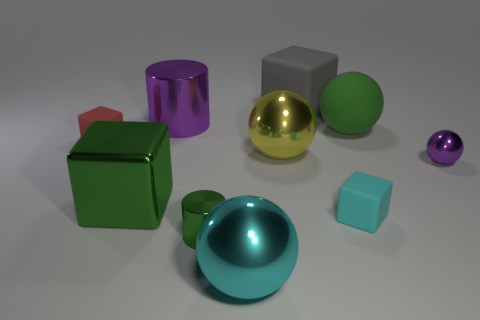Are there fewer green metal things than red rubber objects?
Give a very brief answer. No. How many small purple objects have the same material as the small green cylinder?
Offer a very short reply. 1. There is a small ball that is made of the same material as the tiny green cylinder; what is its color?
Give a very brief answer. Purple. What is the shape of the big yellow object?
Offer a very short reply. Sphere. How many tiny rubber objects have the same color as the rubber sphere?
Provide a succinct answer. 0. There is a yellow metallic object that is the same size as the green shiny block; what shape is it?
Offer a terse response. Sphere. Is there a yellow object that has the same size as the green cube?
Give a very brief answer. Yes. There is a purple ball that is the same size as the red cube; what is its material?
Provide a short and direct response. Metal. How big is the matte cube to the left of the large cyan metallic sphere that is left of the matte sphere?
Your response must be concise. Small. There is a purple metallic thing in front of the red matte block; is it the same size as the purple cylinder?
Make the answer very short. No. 